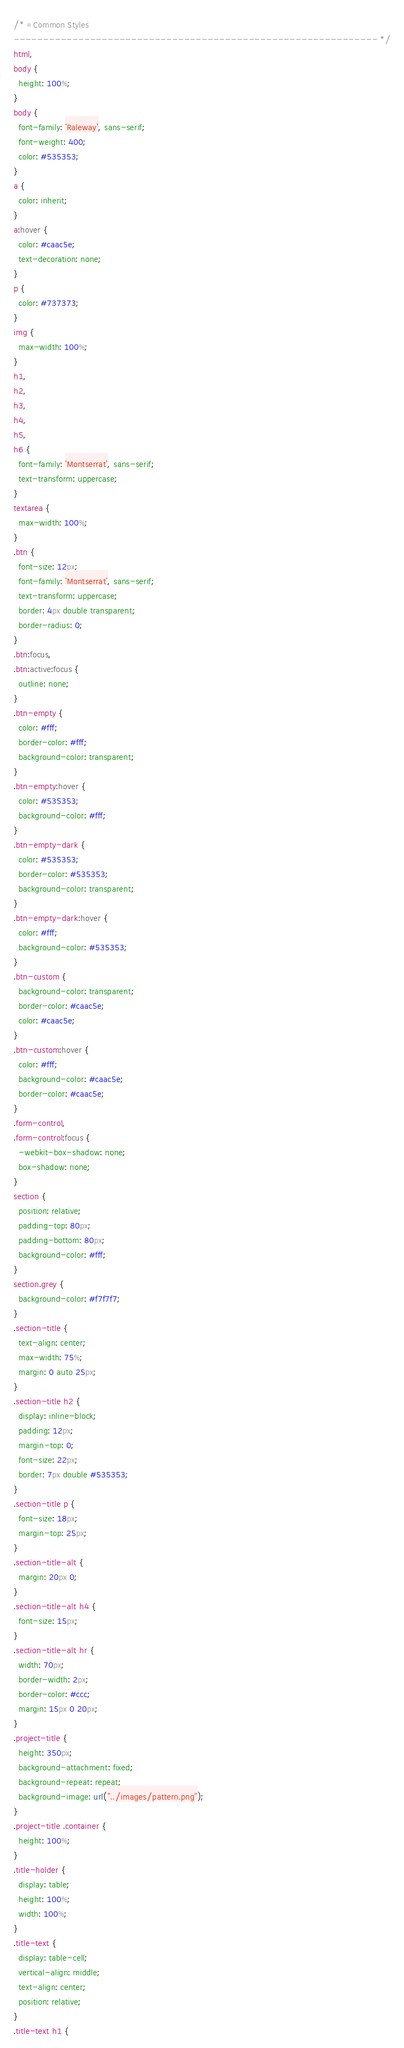Convert code to text. <code><loc_0><loc_0><loc_500><loc_500><_CSS_>/* =Common Styles
-------------------------------------------------------------- */
html,
body {
  height: 100%;
}
body {
  font-family: 'Raleway', sans-serif;
  font-weight: 400;
  color: #535353;
}
a {
  color: inherit;
}
a:hover {
  color: #caac5e;
  text-decoration: none;
}
p {
  color: #737373;
}
img {
  max-width: 100%;
}
h1,
h2,
h3,
h4,
h5,
h6 {
  font-family: 'Montserrat', sans-serif;
  text-transform: uppercase;
}
textarea {
  max-width: 100%;
}
.btn {
  font-size: 12px;
  font-family: 'Montserrat', sans-serif;
  text-transform: uppercase;
  border: 4px double transparent;
  border-radius: 0;
}
.btn:focus,
.btn:active:focus {
  outline: none;
}
.btn-empty {
  color: #fff;
  border-color: #fff;
  background-color: transparent;
}
.btn-empty:hover {
  color: #535353;
  background-color: #fff;
}
.btn-empty-dark {
  color: #535353;
  border-color: #535353;
  background-color: transparent;
}
.btn-empty-dark:hover {
  color: #fff;
  background-color: #535353;
}
.btn-custom {
  background-color: transparent;
  border-color: #caac5e;
  color: #caac5e;
}
.btn-custom:hover {
  color: #fff;
  background-color: #caac5e;
  border-color: #caac5e;
}
.form-control,
.form-control:focus {
  -webkit-box-shadow: none;
  box-shadow: none;
}
section {
  position: relative;
  padding-top: 80px;
  padding-bottom: 80px;
  background-color: #fff;
}
section.grey {
  background-color: #f7f7f7;
}
.section-title {
  text-align: center;
  max-width: 75%;
  margin: 0 auto 25px;
}
.section-title h2 {
  display: inline-block;
  padding: 12px;
  margin-top: 0;
  font-size: 22px;
  border: 7px double #535353;
}
.section-title p {
  font-size: 18px;
  margin-top: 25px;
}
.section-title-alt {
  margin: 20px 0;
}
.section-title-alt h4 {
  font-size: 15px;
}
.section-title-alt hr {
  width: 70px;
  border-width: 2px;
  border-color: #ccc;
  margin: 15px 0 20px;
}
.project-title {
  height: 350px;
  background-attachment: fixed;
  background-repeat: repeat;
  background-image: url("../images/pattern.png");
}
.project-title .container {
  height: 100%;
}
.title-holder {
  display: table;
  height: 100%;
  width: 100%;
}
.title-text {
  display: table-cell;
  vertical-align: middle;
  text-align: center;
  position: relative;
}
.title-text h1 {</code> 